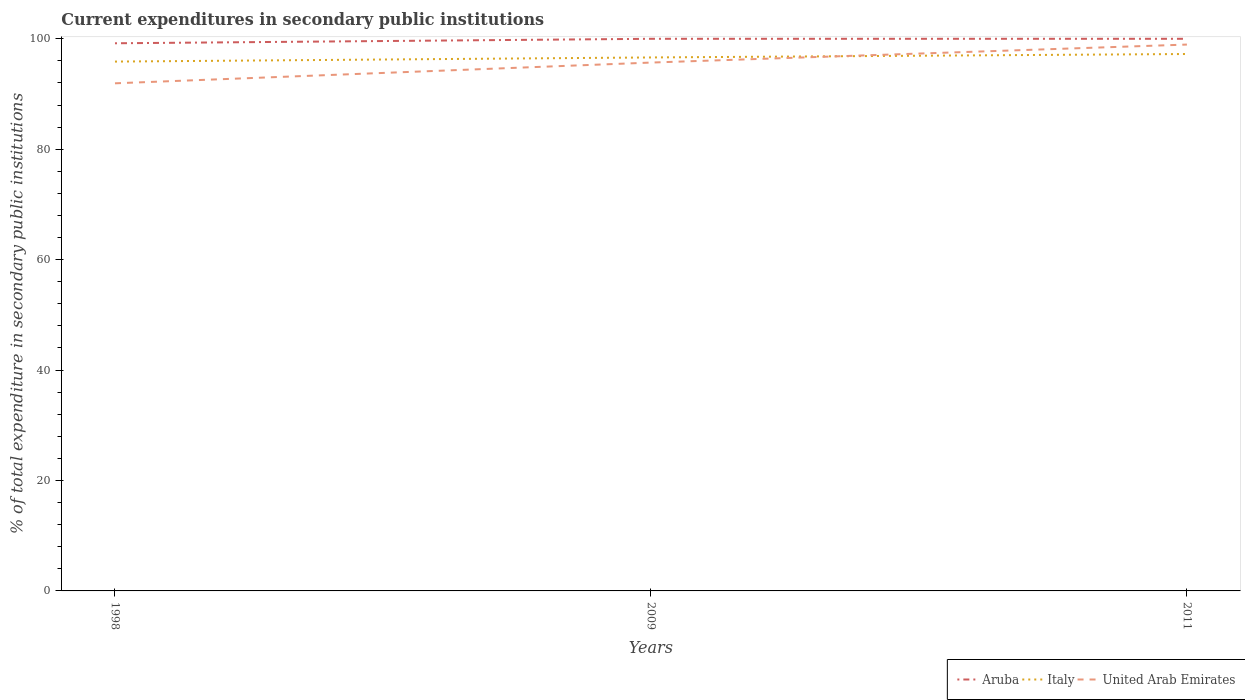How many different coloured lines are there?
Give a very brief answer. 3. Does the line corresponding to Aruba intersect with the line corresponding to Italy?
Provide a succinct answer. No. Across all years, what is the maximum current expenditures in secondary public institutions in Italy?
Ensure brevity in your answer.  95.87. In which year was the current expenditures in secondary public institutions in United Arab Emirates maximum?
Offer a very short reply. 1998. What is the total current expenditures in secondary public institutions in Italy in the graph?
Provide a short and direct response. -0.75. What is the difference between the highest and the second highest current expenditures in secondary public institutions in Aruba?
Give a very brief answer. 0.81. What is the difference between the highest and the lowest current expenditures in secondary public institutions in Aruba?
Make the answer very short. 2. How many lines are there?
Offer a very short reply. 3. How many years are there in the graph?
Provide a short and direct response. 3. What is the difference between two consecutive major ticks on the Y-axis?
Make the answer very short. 20. Where does the legend appear in the graph?
Provide a short and direct response. Bottom right. What is the title of the graph?
Your answer should be very brief. Current expenditures in secondary public institutions. What is the label or title of the X-axis?
Offer a terse response. Years. What is the label or title of the Y-axis?
Offer a terse response. % of total expenditure in secondary public institutions. What is the % of total expenditure in secondary public institutions in Aruba in 1998?
Provide a short and direct response. 99.19. What is the % of total expenditure in secondary public institutions of Italy in 1998?
Give a very brief answer. 95.87. What is the % of total expenditure in secondary public institutions of United Arab Emirates in 1998?
Your answer should be compact. 91.94. What is the % of total expenditure in secondary public institutions in Aruba in 2009?
Your answer should be very brief. 100. What is the % of total expenditure in secondary public institutions of Italy in 2009?
Provide a short and direct response. 96.62. What is the % of total expenditure in secondary public institutions of United Arab Emirates in 2009?
Offer a very short reply. 95.7. What is the % of total expenditure in secondary public institutions of Italy in 2011?
Ensure brevity in your answer.  97.25. What is the % of total expenditure in secondary public institutions of United Arab Emirates in 2011?
Make the answer very short. 98.96. Across all years, what is the maximum % of total expenditure in secondary public institutions of Italy?
Keep it short and to the point. 97.25. Across all years, what is the maximum % of total expenditure in secondary public institutions of United Arab Emirates?
Make the answer very short. 98.96. Across all years, what is the minimum % of total expenditure in secondary public institutions in Aruba?
Your answer should be very brief. 99.19. Across all years, what is the minimum % of total expenditure in secondary public institutions in Italy?
Make the answer very short. 95.87. Across all years, what is the minimum % of total expenditure in secondary public institutions in United Arab Emirates?
Keep it short and to the point. 91.94. What is the total % of total expenditure in secondary public institutions in Aruba in the graph?
Offer a terse response. 299.19. What is the total % of total expenditure in secondary public institutions of Italy in the graph?
Offer a terse response. 289.74. What is the total % of total expenditure in secondary public institutions of United Arab Emirates in the graph?
Provide a succinct answer. 286.59. What is the difference between the % of total expenditure in secondary public institutions of Aruba in 1998 and that in 2009?
Provide a succinct answer. -0.81. What is the difference between the % of total expenditure in secondary public institutions of Italy in 1998 and that in 2009?
Your answer should be very brief. -0.75. What is the difference between the % of total expenditure in secondary public institutions in United Arab Emirates in 1998 and that in 2009?
Ensure brevity in your answer.  -3.76. What is the difference between the % of total expenditure in secondary public institutions in Aruba in 1998 and that in 2011?
Ensure brevity in your answer.  -0.81. What is the difference between the % of total expenditure in secondary public institutions of Italy in 1998 and that in 2011?
Your answer should be compact. -1.37. What is the difference between the % of total expenditure in secondary public institutions of United Arab Emirates in 1998 and that in 2011?
Offer a terse response. -7.02. What is the difference between the % of total expenditure in secondary public institutions of Aruba in 2009 and that in 2011?
Provide a succinct answer. 0. What is the difference between the % of total expenditure in secondary public institutions in Italy in 2009 and that in 2011?
Provide a succinct answer. -0.62. What is the difference between the % of total expenditure in secondary public institutions in United Arab Emirates in 2009 and that in 2011?
Give a very brief answer. -3.26. What is the difference between the % of total expenditure in secondary public institutions of Aruba in 1998 and the % of total expenditure in secondary public institutions of Italy in 2009?
Your answer should be very brief. 2.57. What is the difference between the % of total expenditure in secondary public institutions of Aruba in 1998 and the % of total expenditure in secondary public institutions of United Arab Emirates in 2009?
Your answer should be compact. 3.49. What is the difference between the % of total expenditure in secondary public institutions in Italy in 1998 and the % of total expenditure in secondary public institutions in United Arab Emirates in 2009?
Offer a terse response. 0.18. What is the difference between the % of total expenditure in secondary public institutions of Aruba in 1998 and the % of total expenditure in secondary public institutions of Italy in 2011?
Offer a very short reply. 1.94. What is the difference between the % of total expenditure in secondary public institutions in Aruba in 1998 and the % of total expenditure in secondary public institutions in United Arab Emirates in 2011?
Offer a very short reply. 0.23. What is the difference between the % of total expenditure in secondary public institutions in Italy in 1998 and the % of total expenditure in secondary public institutions in United Arab Emirates in 2011?
Offer a very short reply. -3.08. What is the difference between the % of total expenditure in secondary public institutions of Aruba in 2009 and the % of total expenditure in secondary public institutions of Italy in 2011?
Keep it short and to the point. 2.75. What is the difference between the % of total expenditure in secondary public institutions of Aruba in 2009 and the % of total expenditure in secondary public institutions of United Arab Emirates in 2011?
Your response must be concise. 1.04. What is the difference between the % of total expenditure in secondary public institutions in Italy in 2009 and the % of total expenditure in secondary public institutions in United Arab Emirates in 2011?
Your answer should be very brief. -2.33. What is the average % of total expenditure in secondary public institutions in Aruba per year?
Offer a terse response. 99.73. What is the average % of total expenditure in secondary public institutions of Italy per year?
Provide a succinct answer. 96.58. What is the average % of total expenditure in secondary public institutions in United Arab Emirates per year?
Keep it short and to the point. 95.53. In the year 1998, what is the difference between the % of total expenditure in secondary public institutions of Aruba and % of total expenditure in secondary public institutions of Italy?
Provide a succinct answer. 3.32. In the year 1998, what is the difference between the % of total expenditure in secondary public institutions of Aruba and % of total expenditure in secondary public institutions of United Arab Emirates?
Your answer should be very brief. 7.25. In the year 1998, what is the difference between the % of total expenditure in secondary public institutions of Italy and % of total expenditure in secondary public institutions of United Arab Emirates?
Offer a terse response. 3.94. In the year 2009, what is the difference between the % of total expenditure in secondary public institutions in Aruba and % of total expenditure in secondary public institutions in Italy?
Provide a succinct answer. 3.38. In the year 2009, what is the difference between the % of total expenditure in secondary public institutions of Aruba and % of total expenditure in secondary public institutions of United Arab Emirates?
Provide a short and direct response. 4.3. In the year 2009, what is the difference between the % of total expenditure in secondary public institutions in Italy and % of total expenditure in secondary public institutions in United Arab Emirates?
Your answer should be very brief. 0.93. In the year 2011, what is the difference between the % of total expenditure in secondary public institutions in Aruba and % of total expenditure in secondary public institutions in Italy?
Your answer should be very brief. 2.75. In the year 2011, what is the difference between the % of total expenditure in secondary public institutions of Aruba and % of total expenditure in secondary public institutions of United Arab Emirates?
Provide a short and direct response. 1.04. In the year 2011, what is the difference between the % of total expenditure in secondary public institutions in Italy and % of total expenditure in secondary public institutions in United Arab Emirates?
Offer a terse response. -1.71. What is the ratio of the % of total expenditure in secondary public institutions in Aruba in 1998 to that in 2009?
Provide a short and direct response. 0.99. What is the ratio of the % of total expenditure in secondary public institutions in United Arab Emirates in 1998 to that in 2009?
Your answer should be very brief. 0.96. What is the ratio of the % of total expenditure in secondary public institutions in Aruba in 1998 to that in 2011?
Offer a terse response. 0.99. What is the ratio of the % of total expenditure in secondary public institutions of Italy in 1998 to that in 2011?
Offer a terse response. 0.99. What is the ratio of the % of total expenditure in secondary public institutions of United Arab Emirates in 1998 to that in 2011?
Offer a terse response. 0.93. What is the difference between the highest and the second highest % of total expenditure in secondary public institutions in Aruba?
Make the answer very short. 0. What is the difference between the highest and the second highest % of total expenditure in secondary public institutions of Italy?
Your response must be concise. 0.62. What is the difference between the highest and the second highest % of total expenditure in secondary public institutions of United Arab Emirates?
Provide a short and direct response. 3.26. What is the difference between the highest and the lowest % of total expenditure in secondary public institutions in Aruba?
Make the answer very short. 0.81. What is the difference between the highest and the lowest % of total expenditure in secondary public institutions of Italy?
Provide a short and direct response. 1.37. What is the difference between the highest and the lowest % of total expenditure in secondary public institutions of United Arab Emirates?
Give a very brief answer. 7.02. 